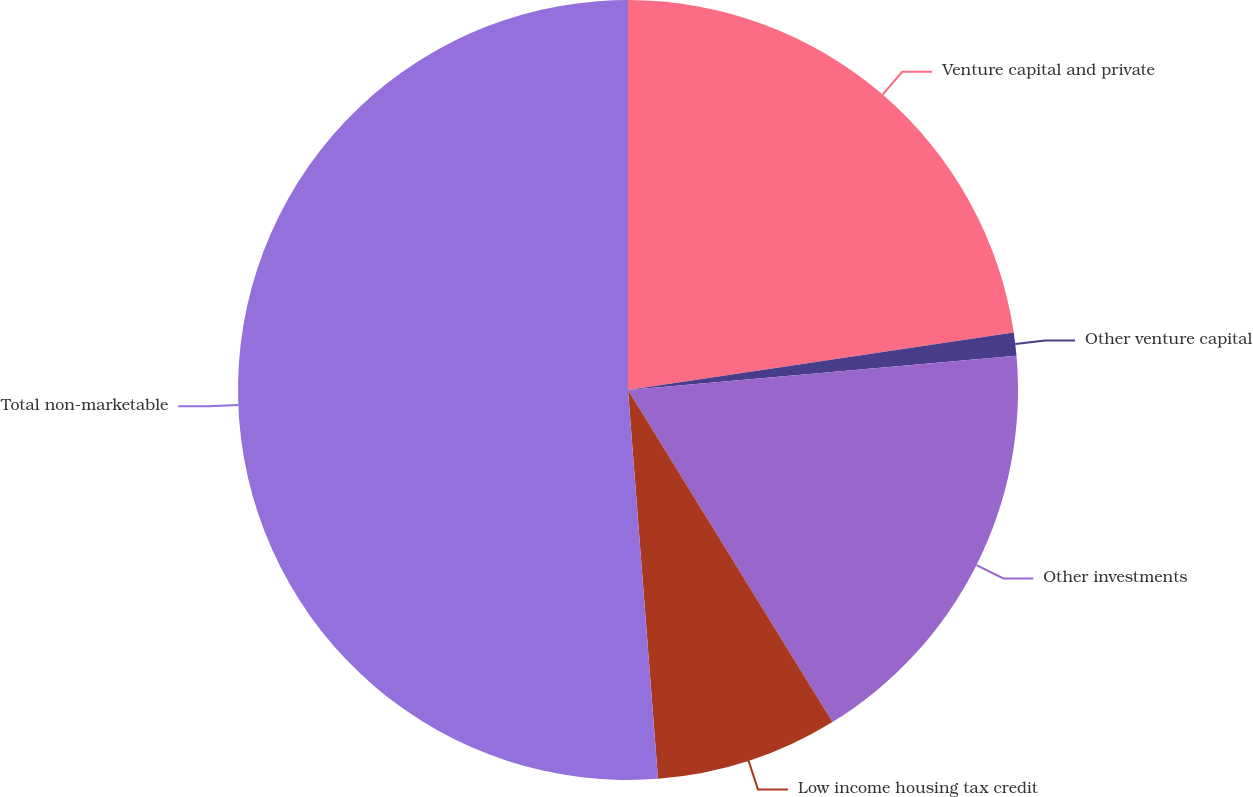Convert chart to OTSL. <chart><loc_0><loc_0><loc_500><loc_500><pie_chart><fcel>Venture capital and private<fcel>Other venture capital<fcel>Other investments<fcel>Low income housing tax credit<fcel>Total non-marketable<nl><fcel>22.64%<fcel>0.96%<fcel>17.61%<fcel>7.56%<fcel>51.22%<nl></chart> 